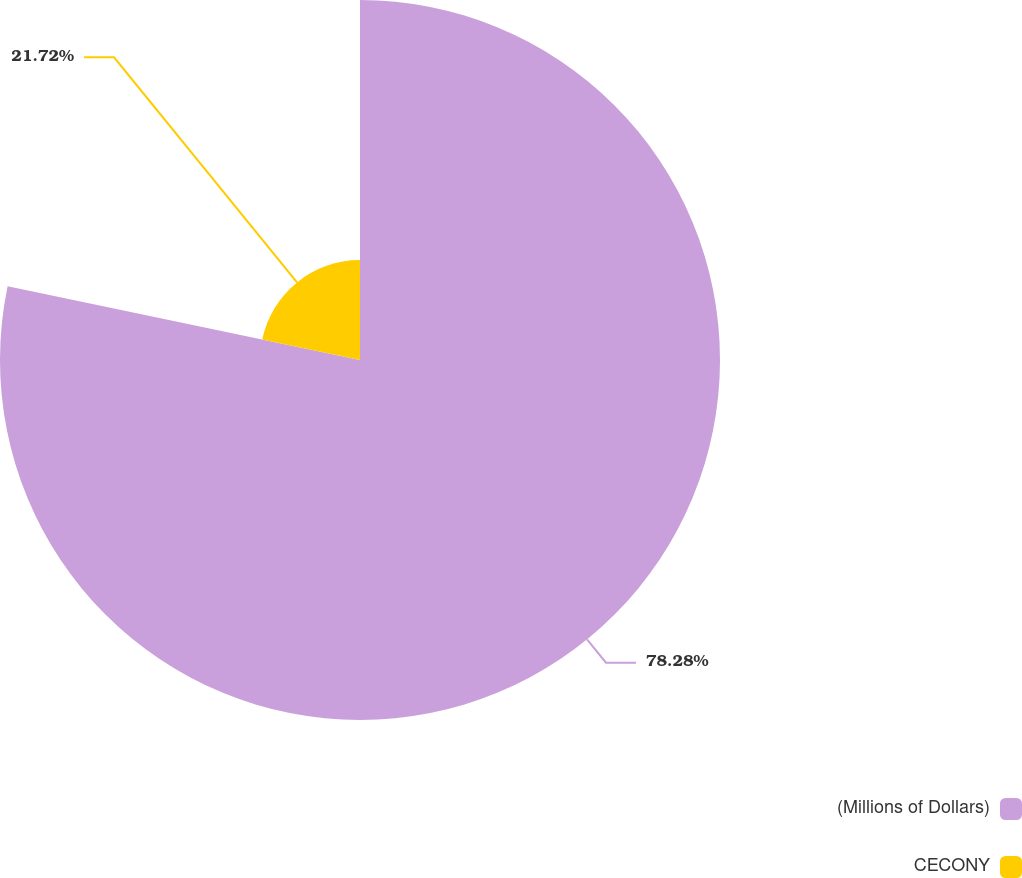<chart> <loc_0><loc_0><loc_500><loc_500><pie_chart><fcel>(Millions of Dollars)<fcel>CECONY<nl><fcel>78.28%<fcel>21.72%<nl></chart> 